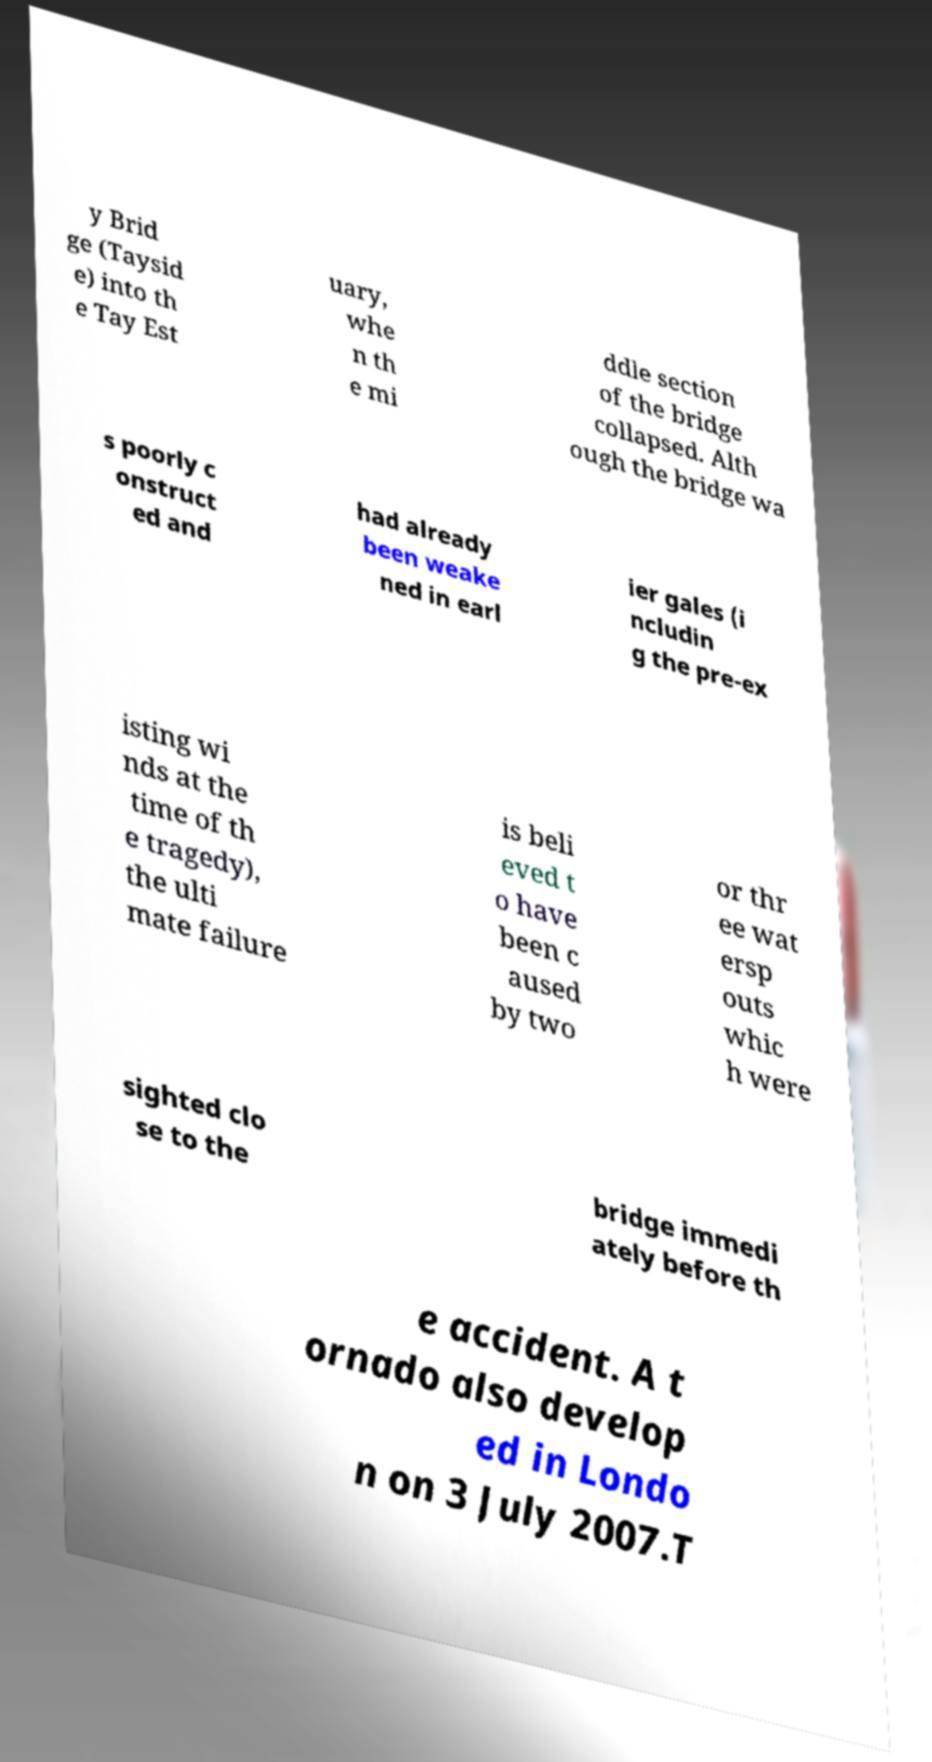I need the written content from this picture converted into text. Can you do that? y Brid ge (Taysid e) into th e Tay Est uary, whe n th e mi ddle section of the bridge collapsed. Alth ough the bridge wa s poorly c onstruct ed and had already been weake ned in earl ier gales (i ncludin g the pre-ex isting wi nds at the time of th e tragedy), the ulti mate failure is beli eved t o have been c aused by two or thr ee wat ersp outs whic h were sighted clo se to the bridge immedi ately before th e accident. A t ornado also develop ed in Londo n on 3 July 2007.T 